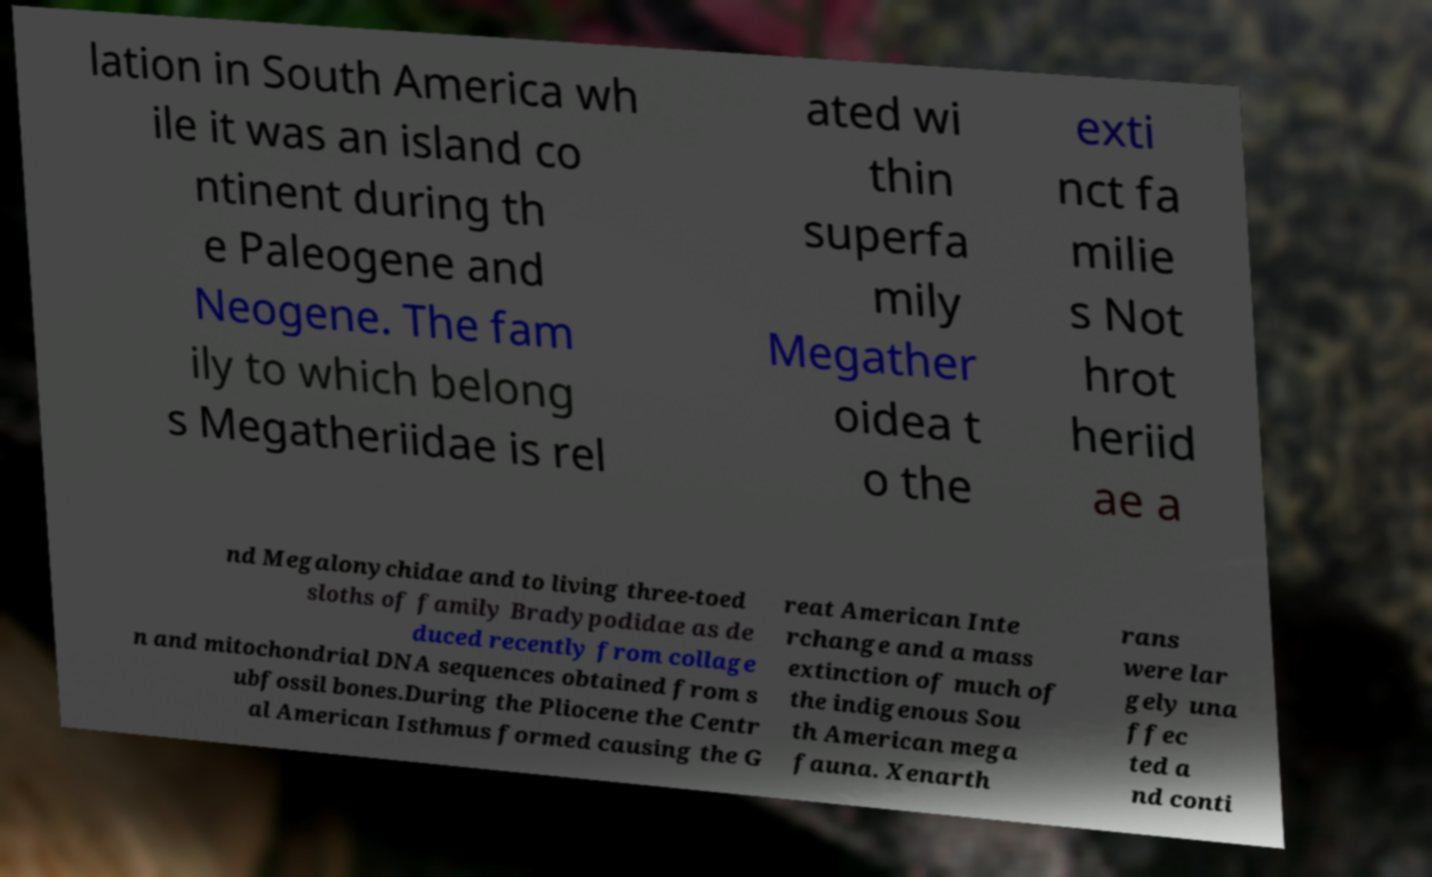Please identify and transcribe the text found in this image. lation in South America wh ile it was an island co ntinent during th e Paleogene and Neogene. The fam ily to which belong s Megatheriidae is rel ated wi thin superfa mily Megather oidea t o the exti nct fa milie s Not hrot heriid ae a nd Megalonychidae and to living three-toed sloths of family Bradypodidae as de duced recently from collage n and mitochondrial DNA sequences obtained from s ubfossil bones.During the Pliocene the Centr al American Isthmus formed causing the G reat American Inte rchange and a mass extinction of much of the indigenous Sou th American mega fauna. Xenarth rans were lar gely una ffec ted a nd conti 